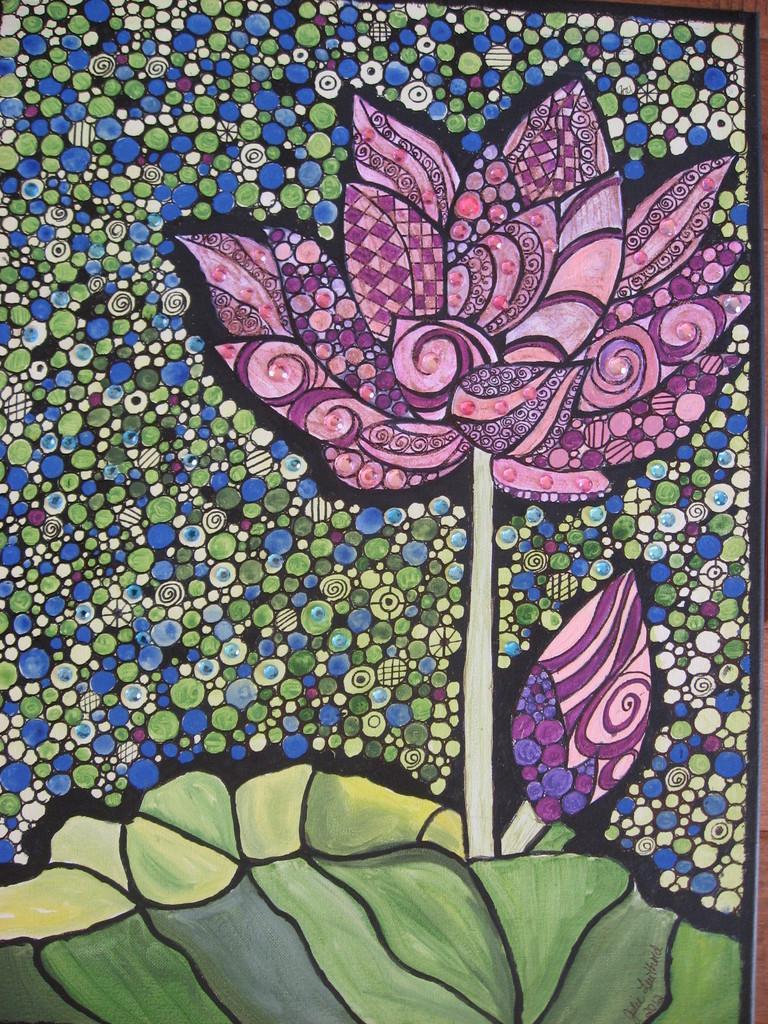Could you give a brief overview of what you see in this image? In this image I can see a flower painted and the flower is in pink color. I can also see leaves in green color and background is in blue, cream and green color. 